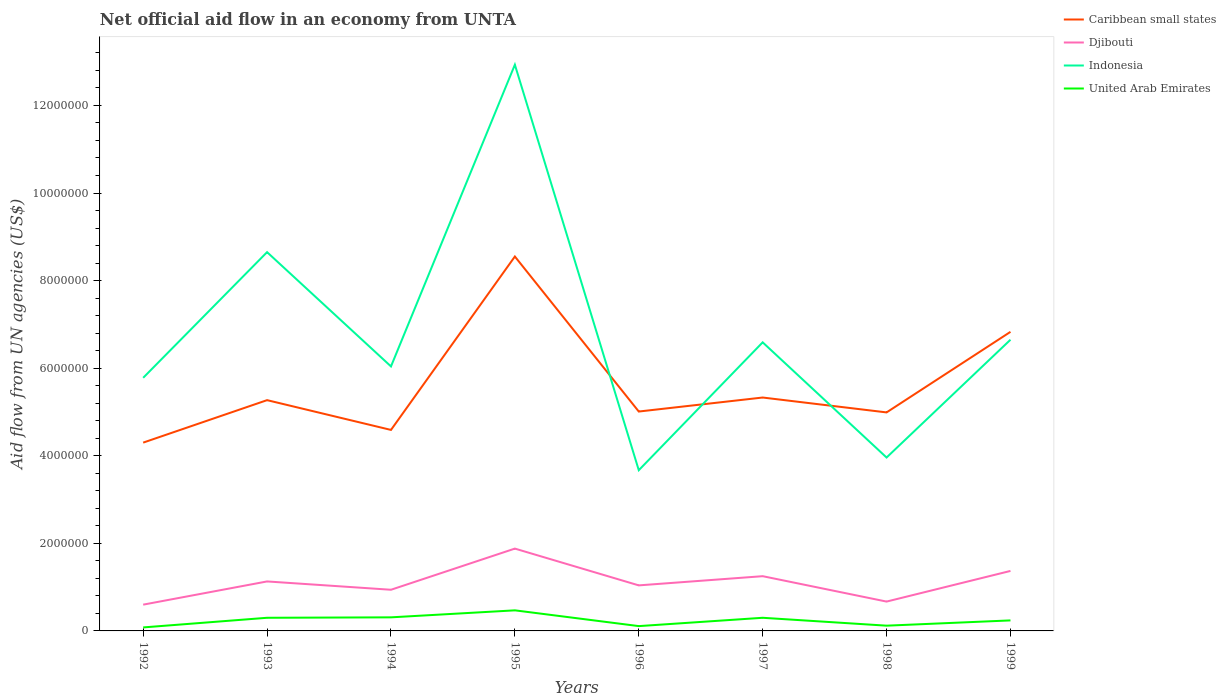How many different coloured lines are there?
Provide a succinct answer. 4. Does the line corresponding to United Arab Emirates intersect with the line corresponding to Djibouti?
Provide a succinct answer. No. Is the number of lines equal to the number of legend labels?
Keep it short and to the point. Yes. Across all years, what is the maximum net official aid flow in Indonesia?
Keep it short and to the point. 3.67e+06. What is the total net official aid flow in Indonesia in the graph?
Make the answer very short. 2.06e+06. What is the difference between the highest and the second highest net official aid flow in United Arab Emirates?
Offer a terse response. 3.90e+05. How many lines are there?
Offer a very short reply. 4. How many years are there in the graph?
Offer a very short reply. 8. Are the values on the major ticks of Y-axis written in scientific E-notation?
Make the answer very short. No. Does the graph contain any zero values?
Keep it short and to the point. No. Does the graph contain grids?
Give a very brief answer. No. Where does the legend appear in the graph?
Your response must be concise. Top right. How many legend labels are there?
Your answer should be compact. 4. How are the legend labels stacked?
Offer a very short reply. Vertical. What is the title of the graph?
Provide a short and direct response. Net official aid flow in an economy from UNTA. What is the label or title of the X-axis?
Your answer should be very brief. Years. What is the label or title of the Y-axis?
Provide a short and direct response. Aid flow from UN agencies (US$). What is the Aid flow from UN agencies (US$) of Caribbean small states in 1992?
Offer a very short reply. 4.30e+06. What is the Aid flow from UN agencies (US$) of Djibouti in 1992?
Give a very brief answer. 6.00e+05. What is the Aid flow from UN agencies (US$) in Indonesia in 1992?
Offer a very short reply. 5.78e+06. What is the Aid flow from UN agencies (US$) of United Arab Emirates in 1992?
Your answer should be very brief. 8.00e+04. What is the Aid flow from UN agencies (US$) of Caribbean small states in 1993?
Your answer should be compact. 5.27e+06. What is the Aid flow from UN agencies (US$) in Djibouti in 1993?
Your answer should be compact. 1.13e+06. What is the Aid flow from UN agencies (US$) of Indonesia in 1993?
Your response must be concise. 8.65e+06. What is the Aid flow from UN agencies (US$) in United Arab Emirates in 1993?
Offer a terse response. 3.00e+05. What is the Aid flow from UN agencies (US$) in Caribbean small states in 1994?
Give a very brief answer. 4.59e+06. What is the Aid flow from UN agencies (US$) in Djibouti in 1994?
Keep it short and to the point. 9.40e+05. What is the Aid flow from UN agencies (US$) in Indonesia in 1994?
Offer a very short reply. 6.04e+06. What is the Aid flow from UN agencies (US$) in United Arab Emirates in 1994?
Give a very brief answer. 3.10e+05. What is the Aid flow from UN agencies (US$) in Caribbean small states in 1995?
Provide a short and direct response. 8.55e+06. What is the Aid flow from UN agencies (US$) of Djibouti in 1995?
Keep it short and to the point. 1.88e+06. What is the Aid flow from UN agencies (US$) of Indonesia in 1995?
Ensure brevity in your answer.  1.29e+07. What is the Aid flow from UN agencies (US$) of United Arab Emirates in 1995?
Your answer should be compact. 4.70e+05. What is the Aid flow from UN agencies (US$) of Caribbean small states in 1996?
Provide a short and direct response. 5.01e+06. What is the Aid flow from UN agencies (US$) of Djibouti in 1996?
Ensure brevity in your answer.  1.04e+06. What is the Aid flow from UN agencies (US$) in Indonesia in 1996?
Offer a very short reply. 3.67e+06. What is the Aid flow from UN agencies (US$) of Caribbean small states in 1997?
Offer a terse response. 5.33e+06. What is the Aid flow from UN agencies (US$) of Djibouti in 1997?
Your response must be concise. 1.25e+06. What is the Aid flow from UN agencies (US$) of Indonesia in 1997?
Your response must be concise. 6.59e+06. What is the Aid flow from UN agencies (US$) of Caribbean small states in 1998?
Your answer should be very brief. 4.99e+06. What is the Aid flow from UN agencies (US$) of Djibouti in 1998?
Offer a very short reply. 6.70e+05. What is the Aid flow from UN agencies (US$) of Indonesia in 1998?
Offer a very short reply. 3.96e+06. What is the Aid flow from UN agencies (US$) in Caribbean small states in 1999?
Provide a short and direct response. 6.83e+06. What is the Aid flow from UN agencies (US$) in Djibouti in 1999?
Give a very brief answer. 1.37e+06. What is the Aid flow from UN agencies (US$) of Indonesia in 1999?
Provide a short and direct response. 6.65e+06. Across all years, what is the maximum Aid flow from UN agencies (US$) of Caribbean small states?
Make the answer very short. 8.55e+06. Across all years, what is the maximum Aid flow from UN agencies (US$) of Djibouti?
Your answer should be compact. 1.88e+06. Across all years, what is the maximum Aid flow from UN agencies (US$) in Indonesia?
Your response must be concise. 1.29e+07. Across all years, what is the maximum Aid flow from UN agencies (US$) of United Arab Emirates?
Ensure brevity in your answer.  4.70e+05. Across all years, what is the minimum Aid flow from UN agencies (US$) of Caribbean small states?
Offer a very short reply. 4.30e+06. Across all years, what is the minimum Aid flow from UN agencies (US$) of Djibouti?
Keep it short and to the point. 6.00e+05. Across all years, what is the minimum Aid flow from UN agencies (US$) of Indonesia?
Offer a terse response. 3.67e+06. What is the total Aid flow from UN agencies (US$) of Caribbean small states in the graph?
Give a very brief answer. 4.49e+07. What is the total Aid flow from UN agencies (US$) of Djibouti in the graph?
Ensure brevity in your answer.  8.88e+06. What is the total Aid flow from UN agencies (US$) of Indonesia in the graph?
Give a very brief answer. 5.43e+07. What is the total Aid flow from UN agencies (US$) in United Arab Emirates in the graph?
Keep it short and to the point. 1.93e+06. What is the difference between the Aid flow from UN agencies (US$) in Caribbean small states in 1992 and that in 1993?
Offer a very short reply. -9.70e+05. What is the difference between the Aid flow from UN agencies (US$) in Djibouti in 1992 and that in 1993?
Your answer should be very brief. -5.30e+05. What is the difference between the Aid flow from UN agencies (US$) in Indonesia in 1992 and that in 1993?
Your answer should be very brief. -2.87e+06. What is the difference between the Aid flow from UN agencies (US$) of United Arab Emirates in 1992 and that in 1993?
Ensure brevity in your answer.  -2.20e+05. What is the difference between the Aid flow from UN agencies (US$) of Caribbean small states in 1992 and that in 1994?
Keep it short and to the point. -2.90e+05. What is the difference between the Aid flow from UN agencies (US$) of Djibouti in 1992 and that in 1994?
Make the answer very short. -3.40e+05. What is the difference between the Aid flow from UN agencies (US$) in Caribbean small states in 1992 and that in 1995?
Provide a short and direct response. -4.25e+06. What is the difference between the Aid flow from UN agencies (US$) of Djibouti in 1992 and that in 1995?
Offer a very short reply. -1.28e+06. What is the difference between the Aid flow from UN agencies (US$) of Indonesia in 1992 and that in 1995?
Give a very brief answer. -7.15e+06. What is the difference between the Aid flow from UN agencies (US$) in United Arab Emirates in 1992 and that in 1995?
Your response must be concise. -3.90e+05. What is the difference between the Aid flow from UN agencies (US$) in Caribbean small states in 1992 and that in 1996?
Your answer should be compact. -7.10e+05. What is the difference between the Aid flow from UN agencies (US$) of Djibouti in 1992 and that in 1996?
Your answer should be compact. -4.40e+05. What is the difference between the Aid flow from UN agencies (US$) of Indonesia in 1992 and that in 1996?
Keep it short and to the point. 2.11e+06. What is the difference between the Aid flow from UN agencies (US$) in United Arab Emirates in 1992 and that in 1996?
Provide a short and direct response. -3.00e+04. What is the difference between the Aid flow from UN agencies (US$) of Caribbean small states in 1992 and that in 1997?
Ensure brevity in your answer.  -1.03e+06. What is the difference between the Aid flow from UN agencies (US$) of Djibouti in 1992 and that in 1997?
Your answer should be compact. -6.50e+05. What is the difference between the Aid flow from UN agencies (US$) of Indonesia in 1992 and that in 1997?
Provide a succinct answer. -8.10e+05. What is the difference between the Aid flow from UN agencies (US$) of United Arab Emirates in 1992 and that in 1997?
Ensure brevity in your answer.  -2.20e+05. What is the difference between the Aid flow from UN agencies (US$) of Caribbean small states in 1992 and that in 1998?
Provide a succinct answer. -6.90e+05. What is the difference between the Aid flow from UN agencies (US$) of Djibouti in 1992 and that in 1998?
Keep it short and to the point. -7.00e+04. What is the difference between the Aid flow from UN agencies (US$) in Indonesia in 1992 and that in 1998?
Ensure brevity in your answer.  1.82e+06. What is the difference between the Aid flow from UN agencies (US$) of United Arab Emirates in 1992 and that in 1998?
Provide a short and direct response. -4.00e+04. What is the difference between the Aid flow from UN agencies (US$) in Caribbean small states in 1992 and that in 1999?
Give a very brief answer. -2.53e+06. What is the difference between the Aid flow from UN agencies (US$) of Djibouti in 1992 and that in 1999?
Your response must be concise. -7.70e+05. What is the difference between the Aid flow from UN agencies (US$) in Indonesia in 1992 and that in 1999?
Ensure brevity in your answer.  -8.70e+05. What is the difference between the Aid flow from UN agencies (US$) in United Arab Emirates in 1992 and that in 1999?
Provide a succinct answer. -1.60e+05. What is the difference between the Aid flow from UN agencies (US$) of Caribbean small states in 1993 and that in 1994?
Ensure brevity in your answer.  6.80e+05. What is the difference between the Aid flow from UN agencies (US$) in Indonesia in 1993 and that in 1994?
Ensure brevity in your answer.  2.61e+06. What is the difference between the Aid flow from UN agencies (US$) in Caribbean small states in 1993 and that in 1995?
Provide a short and direct response. -3.28e+06. What is the difference between the Aid flow from UN agencies (US$) in Djibouti in 1993 and that in 1995?
Your response must be concise. -7.50e+05. What is the difference between the Aid flow from UN agencies (US$) in Indonesia in 1993 and that in 1995?
Give a very brief answer. -4.28e+06. What is the difference between the Aid flow from UN agencies (US$) of Djibouti in 1993 and that in 1996?
Provide a succinct answer. 9.00e+04. What is the difference between the Aid flow from UN agencies (US$) of Indonesia in 1993 and that in 1996?
Keep it short and to the point. 4.98e+06. What is the difference between the Aid flow from UN agencies (US$) in United Arab Emirates in 1993 and that in 1996?
Make the answer very short. 1.90e+05. What is the difference between the Aid flow from UN agencies (US$) in Indonesia in 1993 and that in 1997?
Keep it short and to the point. 2.06e+06. What is the difference between the Aid flow from UN agencies (US$) in United Arab Emirates in 1993 and that in 1997?
Provide a succinct answer. 0. What is the difference between the Aid flow from UN agencies (US$) in Djibouti in 1993 and that in 1998?
Your answer should be compact. 4.60e+05. What is the difference between the Aid flow from UN agencies (US$) of Indonesia in 1993 and that in 1998?
Ensure brevity in your answer.  4.69e+06. What is the difference between the Aid flow from UN agencies (US$) in United Arab Emirates in 1993 and that in 1998?
Keep it short and to the point. 1.80e+05. What is the difference between the Aid flow from UN agencies (US$) in Caribbean small states in 1993 and that in 1999?
Your answer should be compact. -1.56e+06. What is the difference between the Aid flow from UN agencies (US$) of Djibouti in 1993 and that in 1999?
Provide a succinct answer. -2.40e+05. What is the difference between the Aid flow from UN agencies (US$) in Caribbean small states in 1994 and that in 1995?
Provide a succinct answer. -3.96e+06. What is the difference between the Aid flow from UN agencies (US$) of Djibouti in 1994 and that in 1995?
Make the answer very short. -9.40e+05. What is the difference between the Aid flow from UN agencies (US$) in Indonesia in 1994 and that in 1995?
Your response must be concise. -6.89e+06. What is the difference between the Aid flow from UN agencies (US$) in Caribbean small states in 1994 and that in 1996?
Offer a very short reply. -4.20e+05. What is the difference between the Aid flow from UN agencies (US$) in Indonesia in 1994 and that in 1996?
Keep it short and to the point. 2.37e+06. What is the difference between the Aid flow from UN agencies (US$) in United Arab Emirates in 1994 and that in 1996?
Your response must be concise. 2.00e+05. What is the difference between the Aid flow from UN agencies (US$) in Caribbean small states in 1994 and that in 1997?
Your answer should be very brief. -7.40e+05. What is the difference between the Aid flow from UN agencies (US$) in Djibouti in 1994 and that in 1997?
Provide a succinct answer. -3.10e+05. What is the difference between the Aid flow from UN agencies (US$) of Indonesia in 1994 and that in 1997?
Ensure brevity in your answer.  -5.50e+05. What is the difference between the Aid flow from UN agencies (US$) of United Arab Emirates in 1994 and that in 1997?
Your answer should be compact. 10000. What is the difference between the Aid flow from UN agencies (US$) in Caribbean small states in 1994 and that in 1998?
Make the answer very short. -4.00e+05. What is the difference between the Aid flow from UN agencies (US$) in Djibouti in 1994 and that in 1998?
Keep it short and to the point. 2.70e+05. What is the difference between the Aid flow from UN agencies (US$) of Indonesia in 1994 and that in 1998?
Make the answer very short. 2.08e+06. What is the difference between the Aid flow from UN agencies (US$) of United Arab Emirates in 1994 and that in 1998?
Ensure brevity in your answer.  1.90e+05. What is the difference between the Aid flow from UN agencies (US$) in Caribbean small states in 1994 and that in 1999?
Keep it short and to the point. -2.24e+06. What is the difference between the Aid flow from UN agencies (US$) of Djibouti in 1994 and that in 1999?
Provide a short and direct response. -4.30e+05. What is the difference between the Aid flow from UN agencies (US$) in Indonesia in 1994 and that in 1999?
Your answer should be very brief. -6.10e+05. What is the difference between the Aid flow from UN agencies (US$) in United Arab Emirates in 1994 and that in 1999?
Your response must be concise. 7.00e+04. What is the difference between the Aid flow from UN agencies (US$) of Caribbean small states in 1995 and that in 1996?
Offer a terse response. 3.54e+06. What is the difference between the Aid flow from UN agencies (US$) in Djibouti in 1995 and that in 1996?
Provide a succinct answer. 8.40e+05. What is the difference between the Aid flow from UN agencies (US$) in Indonesia in 1995 and that in 1996?
Your response must be concise. 9.26e+06. What is the difference between the Aid flow from UN agencies (US$) in Caribbean small states in 1995 and that in 1997?
Your response must be concise. 3.22e+06. What is the difference between the Aid flow from UN agencies (US$) in Djibouti in 1995 and that in 1997?
Ensure brevity in your answer.  6.30e+05. What is the difference between the Aid flow from UN agencies (US$) of Indonesia in 1995 and that in 1997?
Keep it short and to the point. 6.34e+06. What is the difference between the Aid flow from UN agencies (US$) of United Arab Emirates in 1995 and that in 1997?
Provide a short and direct response. 1.70e+05. What is the difference between the Aid flow from UN agencies (US$) of Caribbean small states in 1995 and that in 1998?
Provide a short and direct response. 3.56e+06. What is the difference between the Aid flow from UN agencies (US$) in Djibouti in 1995 and that in 1998?
Give a very brief answer. 1.21e+06. What is the difference between the Aid flow from UN agencies (US$) of Indonesia in 1995 and that in 1998?
Your response must be concise. 8.97e+06. What is the difference between the Aid flow from UN agencies (US$) in Caribbean small states in 1995 and that in 1999?
Offer a terse response. 1.72e+06. What is the difference between the Aid flow from UN agencies (US$) in Djibouti in 1995 and that in 1999?
Give a very brief answer. 5.10e+05. What is the difference between the Aid flow from UN agencies (US$) of Indonesia in 1995 and that in 1999?
Offer a terse response. 6.28e+06. What is the difference between the Aid flow from UN agencies (US$) of United Arab Emirates in 1995 and that in 1999?
Give a very brief answer. 2.30e+05. What is the difference between the Aid flow from UN agencies (US$) in Caribbean small states in 1996 and that in 1997?
Ensure brevity in your answer.  -3.20e+05. What is the difference between the Aid flow from UN agencies (US$) of Djibouti in 1996 and that in 1997?
Provide a short and direct response. -2.10e+05. What is the difference between the Aid flow from UN agencies (US$) in Indonesia in 1996 and that in 1997?
Keep it short and to the point. -2.92e+06. What is the difference between the Aid flow from UN agencies (US$) of United Arab Emirates in 1996 and that in 1997?
Provide a short and direct response. -1.90e+05. What is the difference between the Aid flow from UN agencies (US$) in Djibouti in 1996 and that in 1998?
Offer a terse response. 3.70e+05. What is the difference between the Aid flow from UN agencies (US$) in Caribbean small states in 1996 and that in 1999?
Offer a very short reply. -1.82e+06. What is the difference between the Aid flow from UN agencies (US$) of Djibouti in 1996 and that in 1999?
Your answer should be very brief. -3.30e+05. What is the difference between the Aid flow from UN agencies (US$) in Indonesia in 1996 and that in 1999?
Your answer should be very brief. -2.98e+06. What is the difference between the Aid flow from UN agencies (US$) of United Arab Emirates in 1996 and that in 1999?
Provide a short and direct response. -1.30e+05. What is the difference between the Aid flow from UN agencies (US$) in Caribbean small states in 1997 and that in 1998?
Your response must be concise. 3.40e+05. What is the difference between the Aid flow from UN agencies (US$) of Djibouti in 1997 and that in 1998?
Make the answer very short. 5.80e+05. What is the difference between the Aid flow from UN agencies (US$) in Indonesia in 1997 and that in 1998?
Provide a succinct answer. 2.63e+06. What is the difference between the Aid flow from UN agencies (US$) in Caribbean small states in 1997 and that in 1999?
Your answer should be very brief. -1.50e+06. What is the difference between the Aid flow from UN agencies (US$) of United Arab Emirates in 1997 and that in 1999?
Give a very brief answer. 6.00e+04. What is the difference between the Aid flow from UN agencies (US$) of Caribbean small states in 1998 and that in 1999?
Offer a very short reply. -1.84e+06. What is the difference between the Aid flow from UN agencies (US$) of Djibouti in 1998 and that in 1999?
Ensure brevity in your answer.  -7.00e+05. What is the difference between the Aid flow from UN agencies (US$) in Indonesia in 1998 and that in 1999?
Your answer should be compact. -2.69e+06. What is the difference between the Aid flow from UN agencies (US$) in United Arab Emirates in 1998 and that in 1999?
Your answer should be compact. -1.20e+05. What is the difference between the Aid flow from UN agencies (US$) of Caribbean small states in 1992 and the Aid flow from UN agencies (US$) of Djibouti in 1993?
Offer a terse response. 3.17e+06. What is the difference between the Aid flow from UN agencies (US$) in Caribbean small states in 1992 and the Aid flow from UN agencies (US$) in Indonesia in 1993?
Ensure brevity in your answer.  -4.35e+06. What is the difference between the Aid flow from UN agencies (US$) in Caribbean small states in 1992 and the Aid flow from UN agencies (US$) in United Arab Emirates in 1993?
Your answer should be very brief. 4.00e+06. What is the difference between the Aid flow from UN agencies (US$) of Djibouti in 1992 and the Aid flow from UN agencies (US$) of Indonesia in 1993?
Offer a very short reply. -8.05e+06. What is the difference between the Aid flow from UN agencies (US$) of Indonesia in 1992 and the Aid flow from UN agencies (US$) of United Arab Emirates in 1993?
Offer a very short reply. 5.48e+06. What is the difference between the Aid flow from UN agencies (US$) in Caribbean small states in 1992 and the Aid flow from UN agencies (US$) in Djibouti in 1994?
Your response must be concise. 3.36e+06. What is the difference between the Aid flow from UN agencies (US$) in Caribbean small states in 1992 and the Aid flow from UN agencies (US$) in Indonesia in 1994?
Give a very brief answer. -1.74e+06. What is the difference between the Aid flow from UN agencies (US$) of Caribbean small states in 1992 and the Aid flow from UN agencies (US$) of United Arab Emirates in 1994?
Keep it short and to the point. 3.99e+06. What is the difference between the Aid flow from UN agencies (US$) of Djibouti in 1992 and the Aid flow from UN agencies (US$) of Indonesia in 1994?
Ensure brevity in your answer.  -5.44e+06. What is the difference between the Aid flow from UN agencies (US$) of Indonesia in 1992 and the Aid flow from UN agencies (US$) of United Arab Emirates in 1994?
Give a very brief answer. 5.47e+06. What is the difference between the Aid flow from UN agencies (US$) of Caribbean small states in 1992 and the Aid flow from UN agencies (US$) of Djibouti in 1995?
Provide a short and direct response. 2.42e+06. What is the difference between the Aid flow from UN agencies (US$) in Caribbean small states in 1992 and the Aid flow from UN agencies (US$) in Indonesia in 1995?
Ensure brevity in your answer.  -8.63e+06. What is the difference between the Aid flow from UN agencies (US$) in Caribbean small states in 1992 and the Aid flow from UN agencies (US$) in United Arab Emirates in 1995?
Keep it short and to the point. 3.83e+06. What is the difference between the Aid flow from UN agencies (US$) in Djibouti in 1992 and the Aid flow from UN agencies (US$) in Indonesia in 1995?
Keep it short and to the point. -1.23e+07. What is the difference between the Aid flow from UN agencies (US$) in Djibouti in 1992 and the Aid flow from UN agencies (US$) in United Arab Emirates in 1995?
Offer a terse response. 1.30e+05. What is the difference between the Aid flow from UN agencies (US$) in Indonesia in 1992 and the Aid flow from UN agencies (US$) in United Arab Emirates in 1995?
Provide a succinct answer. 5.31e+06. What is the difference between the Aid flow from UN agencies (US$) of Caribbean small states in 1992 and the Aid flow from UN agencies (US$) of Djibouti in 1996?
Your answer should be very brief. 3.26e+06. What is the difference between the Aid flow from UN agencies (US$) of Caribbean small states in 1992 and the Aid flow from UN agencies (US$) of Indonesia in 1996?
Keep it short and to the point. 6.30e+05. What is the difference between the Aid flow from UN agencies (US$) of Caribbean small states in 1992 and the Aid flow from UN agencies (US$) of United Arab Emirates in 1996?
Your response must be concise. 4.19e+06. What is the difference between the Aid flow from UN agencies (US$) of Djibouti in 1992 and the Aid flow from UN agencies (US$) of Indonesia in 1996?
Give a very brief answer. -3.07e+06. What is the difference between the Aid flow from UN agencies (US$) of Djibouti in 1992 and the Aid flow from UN agencies (US$) of United Arab Emirates in 1996?
Give a very brief answer. 4.90e+05. What is the difference between the Aid flow from UN agencies (US$) in Indonesia in 1992 and the Aid flow from UN agencies (US$) in United Arab Emirates in 1996?
Keep it short and to the point. 5.67e+06. What is the difference between the Aid flow from UN agencies (US$) of Caribbean small states in 1992 and the Aid flow from UN agencies (US$) of Djibouti in 1997?
Offer a very short reply. 3.05e+06. What is the difference between the Aid flow from UN agencies (US$) in Caribbean small states in 1992 and the Aid flow from UN agencies (US$) in Indonesia in 1997?
Offer a terse response. -2.29e+06. What is the difference between the Aid flow from UN agencies (US$) of Caribbean small states in 1992 and the Aid flow from UN agencies (US$) of United Arab Emirates in 1997?
Make the answer very short. 4.00e+06. What is the difference between the Aid flow from UN agencies (US$) in Djibouti in 1992 and the Aid flow from UN agencies (US$) in Indonesia in 1997?
Make the answer very short. -5.99e+06. What is the difference between the Aid flow from UN agencies (US$) of Indonesia in 1992 and the Aid flow from UN agencies (US$) of United Arab Emirates in 1997?
Give a very brief answer. 5.48e+06. What is the difference between the Aid flow from UN agencies (US$) in Caribbean small states in 1992 and the Aid flow from UN agencies (US$) in Djibouti in 1998?
Give a very brief answer. 3.63e+06. What is the difference between the Aid flow from UN agencies (US$) in Caribbean small states in 1992 and the Aid flow from UN agencies (US$) in Indonesia in 1998?
Your answer should be compact. 3.40e+05. What is the difference between the Aid flow from UN agencies (US$) of Caribbean small states in 1992 and the Aid flow from UN agencies (US$) of United Arab Emirates in 1998?
Your answer should be very brief. 4.18e+06. What is the difference between the Aid flow from UN agencies (US$) of Djibouti in 1992 and the Aid flow from UN agencies (US$) of Indonesia in 1998?
Offer a very short reply. -3.36e+06. What is the difference between the Aid flow from UN agencies (US$) of Djibouti in 1992 and the Aid flow from UN agencies (US$) of United Arab Emirates in 1998?
Offer a very short reply. 4.80e+05. What is the difference between the Aid flow from UN agencies (US$) of Indonesia in 1992 and the Aid flow from UN agencies (US$) of United Arab Emirates in 1998?
Offer a very short reply. 5.66e+06. What is the difference between the Aid flow from UN agencies (US$) of Caribbean small states in 1992 and the Aid flow from UN agencies (US$) of Djibouti in 1999?
Keep it short and to the point. 2.93e+06. What is the difference between the Aid flow from UN agencies (US$) of Caribbean small states in 1992 and the Aid flow from UN agencies (US$) of Indonesia in 1999?
Offer a very short reply. -2.35e+06. What is the difference between the Aid flow from UN agencies (US$) in Caribbean small states in 1992 and the Aid flow from UN agencies (US$) in United Arab Emirates in 1999?
Give a very brief answer. 4.06e+06. What is the difference between the Aid flow from UN agencies (US$) in Djibouti in 1992 and the Aid flow from UN agencies (US$) in Indonesia in 1999?
Your answer should be very brief. -6.05e+06. What is the difference between the Aid flow from UN agencies (US$) of Indonesia in 1992 and the Aid flow from UN agencies (US$) of United Arab Emirates in 1999?
Offer a very short reply. 5.54e+06. What is the difference between the Aid flow from UN agencies (US$) in Caribbean small states in 1993 and the Aid flow from UN agencies (US$) in Djibouti in 1994?
Keep it short and to the point. 4.33e+06. What is the difference between the Aid flow from UN agencies (US$) of Caribbean small states in 1993 and the Aid flow from UN agencies (US$) of Indonesia in 1994?
Ensure brevity in your answer.  -7.70e+05. What is the difference between the Aid flow from UN agencies (US$) of Caribbean small states in 1993 and the Aid flow from UN agencies (US$) of United Arab Emirates in 1994?
Ensure brevity in your answer.  4.96e+06. What is the difference between the Aid flow from UN agencies (US$) of Djibouti in 1993 and the Aid flow from UN agencies (US$) of Indonesia in 1994?
Provide a succinct answer. -4.91e+06. What is the difference between the Aid flow from UN agencies (US$) in Djibouti in 1993 and the Aid flow from UN agencies (US$) in United Arab Emirates in 1994?
Your answer should be compact. 8.20e+05. What is the difference between the Aid flow from UN agencies (US$) in Indonesia in 1993 and the Aid flow from UN agencies (US$) in United Arab Emirates in 1994?
Give a very brief answer. 8.34e+06. What is the difference between the Aid flow from UN agencies (US$) in Caribbean small states in 1993 and the Aid flow from UN agencies (US$) in Djibouti in 1995?
Offer a terse response. 3.39e+06. What is the difference between the Aid flow from UN agencies (US$) of Caribbean small states in 1993 and the Aid flow from UN agencies (US$) of Indonesia in 1995?
Provide a succinct answer. -7.66e+06. What is the difference between the Aid flow from UN agencies (US$) in Caribbean small states in 1993 and the Aid flow from UN agencies (US$) in United Arab Emirates in 1995?
Your answer should be compact. 4.80e+06. What is the difference between the Aid flow from UN agencies (US$) of Djibouti in 1993 and the Aid flow from UN agencies (US$) of Indonesia in 1995?
Offer a very short reply. -1.18e+07. What is the difference between the Aid flow from UN agencies (US$) in Djibouti in 1993 and the Aid flow from UN agencies (US$) in United Arab Emirates in 1995?
Keep it short and to the point. 6.60e+05. What is the difference between the Aid flow from UN agencies (US$) in Indonesia in 1993 and the Aid flow from UN agencies (US$) in United Arab Emirates in 1995?
Your answer should be compact. 8.18e+06. What is the difference between the Aid flow from UN agencies (US$) in Caribbean small states in 1993 and the Aid flow from UN agencies (US$) in Djibouti in 1996?
Your answer should be compact. 4.23e+06. What is the difference between the Aid flow from UN agencies (US$) in Caribbean small states in 1993 and the Aid flow from UN agencies (US$) in Indonesia in 1996?
Give a very brief answer. 1.60e+06. What is the difference between the Aid flow from UN agencies (US$) of Caribbean small states in 1993 and the Aid flow from UN agencies (US$) of United Arab Emirates in 1996?
Provide a short and direct response. 5.16e+06. What is the difference between the Aid flow from UN agencies (US$) in Djibouti in 1993 and the Aid flow from UN agencies (US$) in Indonesia in 1996?
Your answer should be very brief. -2.54e+06. What is the difference between the Aid flow from UN agencies (US$) in Djibouti in 1993 and the Aid flow from UN agencies (US$) in United Arab Emirates in 1996?
Keep it short and to the point. 1.02e+06. What is the difference between the Aid flow from UN agencies (US$) in Indonesia in 1993 and the Aid flow from UN agencies (US$) in United Arab Emirates in 1996?
Your response must be concise. 8.54e+06. What is the difference between the Aid flow from UN agencies (US$) in Caribbean small states in 1993 and the Aid flow from UN agencies (US$) in Djibouti in 1997?
Keep it short and to the point. 4.02e+06. What is the difference between the Aid flow from UN agencies (US$) in Caribbean small states in 1993 and the Aid flow from UN agencies (US$) in Indonesia in 1997?
Keep it short and to the point. -1.32e+06. What is the difference between the Aid flow from UN agencies (US$) of Caribbean small states in 1993 and the Aid flow from UN agencies (US$) of United Arab Emirates in 1997?
Your response must be concise. 4.97e+06. What is the difference between the Aid flow from UN agencies (US$) in Djibouti in 1993 and the Aid flow from UN agencies (US$) in Indonesia in 1997?
Make the answer very short. -5.46e+06. What is the difference between the Aid flow from UN agencies (US$) of Djibouti in 1993 and the Aid flow from UN agencies (US$) of United Arab Emirates in 1997?
Make the answer very short. 8.30e+05. What is the difference between the Aid flow from UN agencies (US$) in Indonesia in 1993 and the Aid flow from UN agencies (US$) in United Arab Emirates in 1997?
Provide a short and direct response. 8.35e+06. What is the difference between the Aid flow from UN agencies (US$) of Caribbean small states in 1993 and the Aid flow from UN agencies (US$) of Djibouti in 1998?
Your answer should be compact. 4.60e+06. What is the difference between the Aid flow from UN agencies (US$) in Caribbean small states in 1993 and the Aid flow from UN agencies (US$) in Indonesia in 1998?
Your answer should be compact. 1.31e+06. What is the difference between the Aid flow from UN agencies (US$) of Caribbean small states in 1993 and the Aid flow from UN agencies (US$) of United Arab Emirates in 1998?
Offer a terse response. 5.15e+06. What is the difference between the Aid flow from UN agencies (US$) of Djibouti in 1993 and the Aid flow from UN agencies (US$) of Indonesia in 1998?
Offer a terse response. -2.83e+06. What is the difference between the Aid flow from UN agencies (US$) of Djibouti in 1993 and the Aid flow from UN agencies (US$) of United Arab Emirates in 1998?
Give a very brief answer. 1.01e+06. What is the difference between the Aid flow from UN agencies (US$) of Indonesia in 1993 and the Aid flow from UN agencies (US$) of United Arab Emirates in 1998?
Offer a very short reply. 8.53e+06. What is the difference between the Aid flow from UN agencies (US$) of Caribbean small states in 1993 and the Aid flow from UN agencies (US$) of Djibouti in 1999?
Your response must be concise. 3.90e+06. What is the difference between the Aid flow from UN agencies (US$) of Caribbean small states in 1993 and the Aid flow from UN agencies (US$) of Indonesia in 1999?
Your answer should be compact. -1.38e+06. What is the difference between the Aid flow from UN agencies (US$) of Caribbean small states in 1993 and the Aid flow from UN agencies (US$) of United Arab Emirates in 1999?
Your answer should be compact. 5.03e+06. What is the difference between the Aid flow from UN agencies (US$) in Djibouti in 1993 and the Aid flow from UN agencies (US$) in Indonesia in 1999?
Provide a short and direct response. -5.52e+06. What is the difference between the Aid flow from UN agencies (US$) in Djibouti in 1993 and the Aid flow from UN agencies (US$) in United Arab Emirates in 1999?
Keep it short and to the point. 8.90e+05. What is the difference between the Aid flow from UN agencies (US$) in Indonesia in 1993 and the Aid flow from UN agencies (US$) in United Arab Emirates in 1999?
Give a very brief answer. 8.41e+06. What is the difference between the Aid flow from UN agencies (US$) in Caribbean small states in 1994 and the Aid flow from UN agencies (US$) in Djibouti in 1995?
Your response must be concise. 2.71e+06. What is the difference between the Aid flow from UN agencies (US$) in Caribbean small states in 1994 and the Aid flow from UN agencies (US$) in Indonesia in 1995?
Give a very brief answer. -8.34e+06. What is the difference between the Aid flow from UN agencies (US$) in Caribbean small states in 1994 and the Aid flow from UN agencies (US$) in United Arab Emirates in 1995?
Offer a very short reply. 4.12e+06. What is the difference between the Aid flow from UN agencies (US$) in Djibouti in 1994 and the Aid flow from UN agencies (US$) in Indonesia in 1995?
Give a very brief answer. -1.20e+07. What is the difference between the Aid flow from UN agencies (US$) of Indonesia in 1994 and the Aid flow from UN agencies (US$) of United Arab Emirates in 1995?
Your answer should be compact. 5.57e+06. What is the difference between the Aid flow from UN agencies (US$) in Caribbean small states in 1994 and the Aid flow from UN agencies (US$) in Djibouti in 1996?
Make the answer very short. 3.55e+06. What is the difference between the Aid flow from UN agencies (US$) in Caribbean small states in 1994 and the Aid flow from UN agencies (US$) in Indonesia in 1996?
Your answer should be compact. 9.20e+05. What is the difference between the Aid flow from UN agencies (US$) of Caribbean small states in 1994 and the Aid flow from UN agencies (US$) of United Arab Emirates in 1996?
Offer a terse response. 4.48e+06. What is the difference between the Aid flow from UN agencies (US$) of Djibouti in 1994 and the Aid flow from UN agencies (US$) of Indonesia in 1996?
Your response must be concise. -2.73e+06. What is the difference between the Aid flow from UN agencies (US$) in Djibouti in 1994 and the Aid flow from UN agencies (US$) in United Arab Emirates in 1996?
Offer a very short reply. 8.30e+05. What is the difference between the Aid flow from UN agencies (US$) of Indonesia in 1994 and the Aid flow from UN agencies (US$) of United Arab Emirates in 1996?
Offer a very short reply. 5.93e+06. What is the difference between the Aid flow from UN agencies (US$) of Caribbean small states in 1994 and the Aid flow from UN agencies (US$) of Djibouti in 1997?
Ensure brevity in your answer.  3.34e+06. What is the difference between the Aid flow from UN agencies (US$) of Caribbean small states in 1994 and the Aid flow from UN agencies (US$) of Indonesia in 1997?
Give a very brief answer. -2.00e+06. What is the difference between the Aid flow from UN agencies (US$) of Caribbean small states in 1994 and the Aid flow from UN agencies (US$) of United Arab Emirates in 1997?
Keep it short and to the point. 4.29e+06. What is the difference between the Aid flow from UN agencies (US$) of Djibouti in 1994 and the Aid flow from UN agencies (US$) of Indonesia in 1997?
Keep it short and to the point. -5.65e+06. What is the difference between the Aid flow from UN agencies (US$) of Djibouti in 1994 and the Aid flow from UN agencies (US$) of United Arab Emirates in 1997?
Provide a short and direct response. 6.40e+05. What is the difference between the Aid flow from UN agencies (US$) in Indonesia in 1994 and the Aid flow from UN agencies (US$) in United Arab Emirates in 1997?
Make the answer very short. 5.74e+06. What is the difference between the Aid flow from UN agencies (US$) of Caribbean small states in 1994 and the Aid flow from UN agencies (US$) of Djibouti in 1998?
Offer a terse response. 3.92e+06. What is the difference between the Aid flow from UN agencies (US$) of Caribbean small states in 1994 and the Aid flow from UN agencies (US$) of Indonesia in 1998?
Your response must be concise. 6.30e+05. What is the difference between the Aid flow from UN agencies (US$) of Caribbean small states in 1994 and the Aid flow from UN agencies (US$) of United Arab Emirates in 1998?
Give a very brief answer. 4.47e+06. What is the difference between the Aid flow from UN agencies (US$) of Djibouti in 1994 and the Aid flow from UN agencies (US$) of Indonesia in 1998?
Give a very brief answer. -3.02e+06. What is the difference between the Aid flow from UN agencies (US$) in Djibouti in 1994 and the Aid flow from UN agencies (US$) in United Arab Emirates in 1998?
Ensure brevity in your answer.  8.20e+05. What is the difference between the Aid flow from UN agencies (US$) in Indonesia in 1994 and the Aid flow from UN agencies (US$) in United Arab Emirates in 1998?
Make the answer very short. 5.92e+06. What is the difference between the Aid flow from UN agencies (US$) of Caribbean small states in 1994 and the Aid flow from UN agencies (US$) of Djibouti in 1999?
Provide a short and direct response. 3.22e+06. What is the difference between the Aid flow from UN agencies (US$) in Caribbean small states in 1994 and the Aid flow from UN agencies (US$) in Indonesia in 1999?
Offer a terse response. -2.06e+06. What is the difference between the Aid flow from UN agencies (US$) of Caribbean small states in 1994 and the Aid flow from UN agencies (US$) of United Arab Emirates in 1999?
Your response must be concise. 4.35e+06. What is the difference between the Aid flow from UN agencies (US$) in Djibouti in 1994 and the Aid flow from UN agencies (US$) in Indonesia in 1999?
Your answer should be compact. -5.71e+06. What is the difference between the Aid flow from UN agencies (US$) of Indonesia in 1994 and the Aid flow from UN agencies (US$) of United Arab Emirates in 1999?
Provide a succinct answer. 5.80e+06. What is the difference between the Aid flow from UN agencies (US$) in Caribbean small states in 1995 and the Aid flow from UN agencies (US$) in Djibouti in 1996?
Your response must be concise. 7.51e+06. What is the difference between the Aid flow from UN agencies (US$) in Caribbean small states in 1995 and the Aid flow from UN agencies (US$) in Indonesia in 1996?
Your answer should be very brief. 4.88e+06. What is the difference between the Aid flow from UN agencies (US$) of Caribbean small states in 1995 and the Aid flow from UN agencies (US$) of United Arab Emirates in 1996?
Offer a very short reply. 8.44e+06. What is the difference between the Aid flow from UN agencies (US$) in Djibouti in 1995 and the Aid flow from UN agencies (US$) in Indonesia in 1996?
Give a very brief answer. -1.79e+06. What is the difference between the Aid flow from UN agencies (US$) in Djibouti in 1995 and the Aid flow from UN agencies (US$) in United Arab Emirates in 1996?
Provide a succinct answer. 1.77e+06. What is the difference between the Aid flow from UN agencies (US$) of Indonesia in 1995 and the Aid flow from UN agencies (US$) of United Arab Emirates in 1996?
Your answer should be very brief. 1.28e+07. What is the difference between the Aid flow from UN agencies (US$) in Caribbean small states in 1995 and the Aid flow from UN agencies (US$) in Djibouti in 1997?
Your answer should be very brief. 7.30e+06. What is the difference between the Aid flow from UN agencies (US$) of Caribbean small states in 1995 and the Aid flow from UN agencies (US$) of Indonesia in 1997?
Your response must be concise. 1.96e+06. What is the difference between the Aid flow from UN agencies (US$) in Caribbean small states in 1995 and the Aid flow from UN agencies (US$) in United Arab Emirates in 1997?
Make the answer very short. 8.25e+06. What is the difference between the Aid flow from UN agencies (US$) of Djibouti in 1995 and the Aid flow from UN agencies (US$) of Indonesia in 1997?
Provide a succinct answer. -4.71e+06. What is the difference between the Aid flow from UN agencies (US$) in Djibouti in 1995 and the Aid flow from UN agencies (US$) in United Arab Emirates in 1997?
Make the answer very short. 1.58e+06. What is the difference between the Aid flow from UN agencies (US$) in Indonesia in 1995 and the Aid flow from UN agencies (US$) in United Arab Emirates in 1997?
Provide a short and direct response. 1.26e+07. What is the difference between the Aid flow from UN agencies (US$) in Caribbean small states in 1995 and the Aid flow from UN agencies (US$) in Djibouti in 1998?
Make the answer very short. 7.88e+06. What is the difference between the Aid flow from UN agencies (US$) of Caribbean small states in 1995 and the Aid flow from UN agencies (US$) of Indonesia in 1998?
Your answer should be compact. 4.59e+06. What is the difference between the Aid flow from UN agencies (US$) of Caribbean small states in 1995 and the Aid flow from UN agencies (US$) of United Arab Emirates in 1998?
Provide a short and direct response. 8.43e+06. What is the difference between the Aid flow from UN agencies (US$) of Djibouti in 1995 and the Aid flow from UN agencies (US$) of Indonesia in 1998?
Keep it short and to the point. -2.08e+06. What is the difference between the Aid flow from UN agencies (US$) in Djibouti in 1995 and the Aid flow from UN agencies (US$) in United Arab Emirates in 1998?
Keep it short and to the point. 1.76e+06. What is the difference between the Aid flow from UN agencies (US$) of Indonesia in 1995 and the Aid flow from UN agencies (US$) of United Arab Emirates in 1998?
Ensure brevity in your answer.  1.28e+07. What is the difference between the Aid flow from UN agencies (US$) in Caribbean small states in 1995 and the Aid flow from UN agencies (US$) in Djibouti in 1999?
Your answer should be very brief. 7.18e+06. What is the difference between the Aid flow from UN agencies (US$) in Caribbean small states in 1995 and the Aid flow from UN agencies (US$) in Indonesia in 1999?
Give a very brief answer. 1.90e+06. What is the difference between the Aid flow from UN agencies (US$) in Caribbean small states in 1995 and the Aid flow from UN agencies (US$) in United Arab Emirates in 1999?
Your answer should be very brief. 8.31e+06. What is the difference between the Aid flow from UN agencies (US$) in Djibouti in 1995 and the Aid flow from UN agencies (US$) in Indonesia in 1999?
Your answer should be compact. -4.77e+06. What is the difference between the Aid flow from UN agencies (US$) in Djibouti in 1995 and the Aid flow from UN agencies (US$) in United Arab Emirates in 1999?
Provide a succinct answer. 1.64e+06. What is the difference between the Aid flow from UN agencies (US$) of Indonesia in 1995 and the Aid flow from UN agencies (US$) of United Arab Emirates in 1999?
Provide a succinct answer. 1.27e+07. What is the difference between the Aid flow from UN agencies (US$) of Caribbean small states in 1996 and the Aid flow from UN agencies (US$) of Djibouti in 1997?
Give a very brief answer. 3.76e+06. What is the difference between the Aid flow from UN agencies (US$) of Caribbean small states in 1996 and the Aid flow from UN agencies (US$) of Indonesia in 1997?
Offer a very short reply. -1.58e+06. What is the difference between the Aid flow from UN agencies (US$) in Caribbean small states in 1996 and the Aid flow from UN agencies (US$) in United Arab Emirates in 1997?
Provide a succinct answer. 4.71e+06. What is the difference between the Aid flow from UN agencies (US$) of Djibouti in 1996 and the Aid flow from UN agencies (US$) of Indonesia in 1997?
Provide a succinct answer. -5.55e+06. What is the difference between the Aid flow from UN agencies (US$) of Djibouti in 1996 and the Aid flow from UN agencies (US$) of United Arab Emirates in 1997?
Ensure brevity in your answer.  7.40e+05. What is the difference between the Aid flow from UN agencies (US$) of Indonesia in 1996 and the Aid flow from UN agencies (US$) of United Arab Emirates in 1997?
Keep it short and to the point. 3.37e+06. What is the difference between the Aid flow from UN agencies (US$) of Caribbean small states in 1996 and the Aid flow from UN agencies (US$) of Djibouti in 1998?
Give a very brief answer. 4.34e+06. What is the difference between the Aid flow from UN agencies (US$) in Caribbean small states in 1996 and the Aid flow from UN agencies (US$) in Indonesia in 1998?
Your answer should be compact. 1.05e+06. What is the difference between the Aid flow from UN agencies (US$) of Caribbean small states in 1996 and the Aid flow from UN agencies (US$) of United Arab Emirates in 1998?
Keep it short and to the point. 4.89e+06. What is the difference between the Aid flow from UN agencies (US$) of Djibouti in 1996 and the Aid flow from UN agencies (US$) of Indonesia in 1998?
Your answer should be very brief. -2.92e+06. What is the difference between the Aid flow from UN agencies (US$) in Djibouti in 1996 and the Aid flow from UN agencies (US$) in United Arab Emirates in 1998?
Ensure brevity in your answer.  9.20e+05. What is the difference between the Aid flow from UN agencies (US$) of Indonesia in 1996 and the Aid flow from UN agencies (US$) of United Arab Emirates in 1998?
Provide a short and direct response. 3.55e+06. What is the difference between the Aid flow from UN agencies (US$) of Caribbean small states in 1996 and the Aid flow from UN agencies (US$) of Djibouti in 1999?
Your response must be concise. 3.64e+06. What is the difference between the Aid flow from UN agencies (US$) of Caribbean small states in 1996 and the Aid flow from UN agencies (US$) of Indonesia in 1999?
Keep it short and to the point. -1.64e+06. What is the difference between the Aid flow from UN agencies (US$) in Caribbean small states in 1996 and the Aid flow from UN agencies (US$) in United Arab Emirates in 1999?
Provide a succinct answer. 4.77e+06. What is the difference between the Aid flow from UN agencies (US$) of Djibouti in 1996 and the Aid flow from UN agencies (US$) of Indonesia in 1999?
Your answer should be very brief. -5.61e+06. What is the difference between the Aid flow from UN agencies (US$) in Djibouti in 1996 and the Aid flow from UN agencies (US$) in United Arab Emirates in 1999?
Your answer should be very brief. 8.00e+05. What is the difference between the Aid flow from UN agencies (US$) in Indonesia in 1996 and the Aid flow from UN agencies (US$) in United Arab Emirates in 1999?
Provide a succinct answer. 3.43e+06. What is the difference between the Aid flow from UN agencies (US$) of Caribbean small states in 1997 and the Aid flow from UN agencies (US$) of Djibouti in 1998?
Offer a very short reply. 4.66e+06. What is the difference between the Aid flow from UN agencies (US$) in Caribbean small states in 1997 and the Aid flow from UN agencies (US$) in Indonesia in 1998?
Keep it short and to the point. 1.37e+06. What is the difference between the Aid flow from UN agencies (US$) of Caribbean small states in 1997 and the Aid flow from UN agencies (US$) of United Arab Emirates in 1998?
Ensure brevity in your answer.  5.21e+06. What is the difference between the Aid flow from UN agencies (US$) in Djibouti in 1997 and the Aid flow from UN agencies (US$) in Indonesia in 1998?
Provide a short and direct response. -2.71e+06. What is the difference between the Aid flow from UN agencies (US$) of Djibouti in 1997 and the Aid flow from UN agencies (US$) of United Arab Emirates in 1998?
Give a very brief answer. 1.13e+06. What is the difference between the Aid flow from UN agencies (US$) of Indonesia in 1997 and the Aid flow from UN agencies (US$) of United Arab Emirates in 1998?
Provide a short and direct response. 6.47e+06. What is the difference between the Aid flow from UN agencies (US$) in Caribbean small states in 1997 and the Aid flow from UN agencies (US$) in Djibouti in 1999?
Ensure brevity in your answer.  3.96e+06. What is the difference between the Aid flow from UN agencies (US$) of Caribbean small states in 1997 and the Aid flow from UN agencies (US$) of Indonesia in 1999?
Offer a very short reply. -1.32e+06. What is the difference between the Aid flow from UN agencies (US$) of Caribbean small states in 1997 and the Aid flow from UN agencies (US$) of United Arab Emirates in 1999?
Make the answer very short. 5.09e+06. What is the difference between the Aid flow from UN agencies (US$) of Djibouti in 1997 and the Aid flow from UN agencies (US$) of Indonesia in 1999?
Provide a succinct answer. -5.40e+06. What is the difference between the Aid flow from UN agencies (US$) in Djibouti in 1997 and the Aid flow from UN agencies (US$) in United Arab Emirates in 1999?
Ensure brevity in your answer.  1.01e+06. What is the difference between the Aid flow from UN agencies (US$) in Indonesia in 1997 and the Aid flow from UN agencies (US$) in United Arab Emirates in 1999?
Your answer should be compact. 6.35e+06. What is the difference between the Aid flow from UN agencies (US$) of Caribbean small states in 1998 and the Aid flow from UN agencies (US$) of Djibouti in 1999?
Give a very brief answer. 3.62e+06. What is the difference between the Aid flow from UN agencies (US$) of Caribbean small states in 1998 and the Aid flow from UN agencies (US$) of Indonesia in 1999?
Offer a very short reply. -1.66e+06. What is the difference between the Aid flow from UN agencies (US$) of Caribbean small states in 1998 and the Aid flow from UN agencies (US$) of United Arab Emirates in 1999?
Your response must be concise. 4.75e+06. What is the difference between the Aid flow from UN agencies (US$) in Djibouti in 1998 and the Aid flow from UN agencies (US$) in Indonesia in 1999?
Give a very brief answer. -5.98e+06. What is the difference between the Aid flow from UN agencies (US$) of Indonesia in 1998 and the Aid flow from UN agencies (US$) of United Arab Emirates in 1999?
Ensure brevity in your answer.  3.72e+06. What is the average Aid flow from UN agencies (US$) in Caribbean small states per year?
Offer a terse response. 5.61e+06. What is the average Aid flow from UN agencies (US$) in Djibouti per year?
Offer a very short reply. 1.11e+06. What is the average Aid flow from UN agencies (US$) of Indonesia per year?
Provide a succinct answer. 6.78e+06. What is the average Aid flow from UN agencies (US$) in United Arab Emirates per year?
Your response must be concise. 2.41e+05. In the year 1992, what is the difference between the Aid flow from UN agencies (US$) of Caribbean small states and Aid flow from UN agencies (US$) of Djibouti?
Your answer should be compact. 3.70e+06. In the year 1992, what is the difference between the Aid flow from UN agencies (US$) in Caribbean small states and Aid flow from UN agencies (US$) in Indonesia?
Ensure brevity in your answer.  -1.48e+06. In the year 1992, what is the difference between the Aid flow from UN agencies (US$) of Caribbean small states and Aid flow from UN agencies (US$) of United Arab Emirates?
Provide a succinct answer. 4.22e+06. In the year 1992, what is the difference between the Aid flow from UN agencies (US$) in Djibouti and Aid flow from UN agencies (US$) in Indonesia?
Provide a short and direct response. -5.18e+06. In the year 1992, what is the difference between the Aid flow from UN agencies (US$) in Djibouti and Aid flow from UN agencies (US$) in United Arab Emirates?
Keep it short and to the point. 5.20e+05. In the year 1992, what is the difference between the Aid flow from UN agencies (US$) in Indonesia and Aid flow from UN agencies (US$) in United Arab Emirates?
Keep it short and to the point. 5.70e+06. In the year 1993, what is the difference between the Aid flow from UN agencies (US$) of Caribbean small states and Aid flow from UN agencies (US$) of Djibouti?
Give a very brief answer. 4.14e+06. In the year 1993, what is the difference between the Aid flow from UN agencies (US$) of Caribbean small states and Aid flow from UN agencies (US$) of Indonesia?
Offer a very short reply. -3.38e+06. In the year 1993, what is the difference between the Aid flow from UN agencies (US$) of Caribbean small states and Aid flow from UN agencies (US$) of United Arab Emirates?
Make the answer very short. 4.97e+06. In the year 1993, what is the difference between the Aid flow from UN agencies (US$) in Djibouti and Aid flow from UN agencies (US$) in Indonesia?
Keep it short and to the point. -7.52e+06. In the year 1993, what is the difference between the Aid flow from UN agencies (US$) in Djibouti and Aid flow from UN agencies (US$) in United Arab Emirates?
Your answer should be very brief. 8.30e+05. In the year 1993, what is the difference between the Aid flow from UN agencies (US$) in Indonesia and Aid flow from UN agencies (US$) in United Arab Emirates?
Provide a short and direct response. 8.35e+06. In the year 1994, what is the difference between the Aid flow from UN agencies (US$) in Caribbean small states and Aid flow from UN agencies (US$) in Djibouti?
Make the answer very short. 3.65e+06. In the year 1994, what is the difference between the Aid flow from UN agencies (US$) of Caribbean small states and Aid flow from UN agencies (US$) of Indonesia?
Offer a terse response. -1.45e+06. In the year 1994, what is the difference between the Aid flow from UN agencies (US$) in Caribbean small states and Aid flow from UN agencies (US$) in United Arab Emirates?
Provide a short and direct response. 4.28e+06. In the year 1994, what is the difference between the Aid flow from UN agencies (US$) in Djibouti and Aid flow from UN agencies (US$) in Indonesia?
Keep it short and to the point. -5.10e+06. In the year 1994, what is the difference between the Aid flow from UN agencies (US$) of Djibouti and Aid flow from UN agencies (US$) of United Arab Emirates?
Offer a very short reply. 6.30e+05. In the year 1994, what is the difference between the Aid flow from UN agencies (US$) in Indonesia and Aid flow from UN agencies (US$) in United Arab Emirates?
Offer a very short reply. 5.73e+06. In the year 1995, what is the difference between the Aid flow from UN agencies (US$) of Caribbean small states and Aid flow from UN agencies (US$) of Djibouti?
Make the answer very short. 6.67e+06. In the year 1995, what is the difference between the Aid flow from UN agencies (US$) of Caribbean small states and Aid flow from UN agencies (US$) of Indonesia?
Provide a short and direct response. -4.38e+06. In the year 1995, what is the difference between the Aid flow from UN agencies (US$) in Caribbean small states and Aid flow from UN agencies (US$) in United Arab Emirates?
Provide a short and direct response. 8.08e+06. In the year 1995, what is the difference between the Aid flow from UN agencies (US$) of Djibouti and Aid flow from UN agencies (US$) of Indonesia?
Give a very brief answer. -1.10e+07. In the year 1995, what is the difference between the Aid flow from UN agencies (US$) in Djibouti and Aid flow from UN agencies (US$) in United Arab Emirates?
Your response must be concise. 1.41e+06. In the year 1995, what is the difference between the Aid flow from UN agencies (US$) in Indonesia and Aid flow from UN agencies (US$) in United Arab Emirates?
Give a very brief answer. 1.25e+07. In the year 1996, what is the difference between the Aid flow from UN agencies (US$) of Caribbean small states and Aid flow from UN agencies (US$) of Djibouti?
Keep it short and to the point. 3.97e+06. In the year 1996, what is the difference between the Aid flow from UN agencies (US$) in Caribbean small states and Aid flow from UN agencies (US$) in Indonesia?
Offer a terse response. 1.34e+06. In the year 1996, what is the difference between the Aid flow from UN agencies (US$) in Caribbean small states and Aid flow from UN agencies (US$) in United Arab Emirates?
Your answer should be compact. 4.90e+06. In the year 1996, what is the difference between the Aid flow from UN agencies (US$) in Djibouti and Aid flow from UN agencies (US$) in Indonesia?
Offer a very short reply. -2.63e+06. In the year 1996, what is the difference between the Aid flow from UN agencies (US$) in Djibouti and Aid flow from UN agencies (US$) in United Arab Emirates?
Offer a very short reply. 9.30e+05. In the year 1996, what is the difference between the Aid flow from UN agencies (US$) of Indonesia and Aid flow from UN agencies (US$) of United Arab Emirates?
Your answer should be compact. 3.56e+06. In the year 1997, what is the difference between the Aid flow from UN agencies (US$) in Caribbean small states and Aid flow from UN agencies (US$) in Djibouti?
Your answer should be very brief. 4.08e+06. In the year 1997, what is the difference between the Aid flow from UN agencies (US$) in Caribbean small states and Aid flow from UN agencies (US$) in Indonesia?
Offer a very short reply. -1.26e+06. In the year 1997, what is the difference between the Aid flow from UN agencies (US$) in Caribbean small states and Aid flow from UN agencies (US$) in United Arab Emirates?
Keep it short and to the point. 5.03e+06. In the year 1997, what is the difference between the Aid flow from UN agencies (US$) in Djibouti and Aid flow from UN agencies (US$) in Indonesia?
Offer a very short reply. -5.34e+06. In the year 1997, what is the difference between the Aid flow from UN agencies (US$) of Djibouti and Aid flow from UN agencies (US$) of United Arab Emirates?
Keep it short and to the point. 9.50e+05. In the year 1997, what is the difference between the Aid flow from UN agencies (US$) in Indonesia and Aid flow from UN agencies (US$) in United Arab Emirates?
Ensure brevity in your answer.  6.29e+06. In the year 1998, what is the difference between the Aid flow from UN agencies (US$) in Caribbean small states and Aid flow from UN agencies (US$) in Djibouti?
Provide a succinct answer. 4.32e+06. In the year 1998, what is the difference between the Aid flow from UN agencies (US$) in Caribbean small states and Aid flow from UN agencies (US$) in Indonesia?
Your answer should be compact. 1.03e+06. In the year 1998, what is the difference between the Aid flow from UN agencies (US$) in Caribbean small states and Aid flow from UN agencies (US$) in United Arab Emirates?
Keep it short and to the point. 4.87e+06. In the year 1998, what is the difference between the Aid flow from UN agencies (US$) in Djibouti and Aid flow from UN agencies (US$) in Indonesia?
Provide a short and direct response. -3.29e+06. In the year 1998, what is the difference between the Aid flow from UN agencies (US$) in Indonesia and Aid flow from UN agencies (US$) in United Arab Emirates?
Keep it short and to the point. 3.84e+06. In the year 1999, what is the difference between the Aid flow from UN agencies (US$) of Caribbean small states and Aid flow from UN agencies (US$) of Djibouti?
Ensure brevity in your answer.  5.46e+06. In the year 1999, what is the difference between the Aid flow from UN agencies (US$) of Caribbean small states and Aid flow from UN agencies (US$) of Indonesia?
Your answer should be compact. 1.80e+05. In the year 1999, what is the difference between the Aid flow from UN agencies (US$) in Caribbean small states and Aid flow from UN agencies (US$) in United Arab Emirates?
Your response must be concise. 6.59e+06. In the year 1999, what is the difference between the Aid flow from UN agencies (US$) in Djibouti and Aid flow from UN agencies (US$) in Indonesia?
Offer a very short reply. -5.28e+06. In the year 1999, what is the difference between the Aid flow from UN agencies (US$) in Djibouti and Aid flow from UN agencies (US$) in United Arab Emirates?
Offer a terse response. 1.13e+06. In the year 1999, what is the difference between the Aid flow from UN agencies (US$) in Indonesia and Aid flow from UN agencies (US$) in United Arab Emirates?
Offer a terse response. 6.41e+06. What is the ratio of the Aid flow from UN agencies (US$) of Caribbean small states in 1992 to that in 1993?
Provide a short and direct response. 0.82. What is the ratio of the Aid flow from UN agencies (US$) of Djibouti in 1992 to that in 1993?
Your answer should be compact. 0.53. What is the ratio of the Aid flow from UN agencies (US$) in Indonesia in 1992 to that in 1993?
Your answer should be compact. 0.67. What is the ratio of the Aid flow from UN agencies (US$) in United Arab Emirates in 1992 to that in 1993?
Your response must be concise. 0.27. What is the ratio of the Aid flow from UN agencies (US$) of Caribbean small states in 1992 to that in 1994?
Give a very brief answer. 0.94. What is the ratio of the Aid flow from UN agencies (US$) in Djibouti in 1992 to that in 1994?
Give a very brief answer. 0.64. What is the ratio of the Aid flow from UN agencies (US$) of Indonesia in 1992 to that in 1994?
Offer a terse response. 0.96. What is the ratio of the Aid flow from UN agencies (US$) of United Arab Emirates in 1992 to that in 1994?
Your response must be concise. 0.26. What is the ratio of the Aid flow from UN agencies (US$) in Caribbean small states in 1992 to that in 1995?
Provide a short and direct response. 0.5. What is the ratio of the Aid flow from UN agencies (US$) of Djibouti in 1992 to that in 1995?
Provide a short and direct response. 0.32. What is the ratio of the Aid flow from UN agencies (US$) in Indonesia in 1992 to that in 1995?
Provide a succinct answer. 0.45. What is the ratio of the Aid flow from UN agencies (US$) of United Arab Emirates in 1992 to that in 1995?
Provide a short and direct response. 0.17. What is the ratio of the Aid flow from UN agencies (US$) in Caribbean small states in 1992 to that in 1996?
Your answer should be compact. 0.86. What is the ratio of the Aid flow from UN agencies (US$) of Djibouti in 1992 to that in 1996?
Your answer should be very brief. 0.58. What is the ratio of the Aid flow from UN agencies (US$) in Indonesia in 1992 to that in 1996?
Keep it short and to the point. 1.57. What is the ratio of the Aid flow from UN agencies (US$) of United Arab Emirates in 1992 to that in 1996?
Make the answer very short. 0.73. What is the ratio of the Aid flow from UN agencies (US$) of Caribbean small states in 1992 to that in 1997?
Provide a succinct answer. 0.81. What is the ratio of the Aid flow from UN agencies (US$) in Djibouti in 1992 to that in 1997?
Give a very brief answer. 0.48. What is the ratio of the Aid flow from UN agencies (US$) of Indonesia in 1992 to that in 1997?
Offer a very short reply. 0.88. What is the ratio of the Aid flow from UN agencies (US$) of United Arab Emirates in 1992 to that in 1997?
Your answer should be compact. 0.27. What is the ratio of the Aid flow from UN agencies (US$) of Caribbean small states in 1992 to that in 1998?
Give a very brief answer. 0.86. What is the ratio of the Aid flow from UN agencies (US$) of Djibouti in 1992 to that in 1998?
Your answer should be very brief. 0.9. What is the ratio of the Aid flow from UN agencies (US$) in Indonesia in 1992 to that in 1998?
Give a very brief answer. 1.46. What is the ratio of the Aid flow from UN agencies (US$) in United Arab Emirates in 1992 to that in 1998?
Offer a very short reply. 0.67. What is the ratio of the Aid flow from UN agencies (US$) of Caribbean small states in 1992 to that in 1999?
Make the answer very short. 0.63. What is the ratio of the Aid flow from UN agencies (US$) of Djibouti in 1992 to that in 1999?
Your response must be concise. 0.44. What is the ratio of the Aid flow from UN agencies (US$) of Indonesia in 1992 to that in 1999?
Provide a short and direct response. 0.87. What is the ratio of the Aid flow from UN agencies (US$) of United Arab Emirates in 1992 to that in 1999?
Keep it short and to the point. 0.33. What is the ratio of the Aid flow from UN agencies (US$) in Caribbean small states in 1993 to that in 1994?
Your answer should be very brief. 1.15. What is the ratio of the Aid flow from UN agencies (US$) in Djibouti in 1993 to that in 1994?
Provide a succinct answer. 1.2. What is the ratio of the Aid flow from UN agencies (US$) in Indonesia in 1993 to that in 1994?
Offer a terse response. 1.43. What is the ratio of the Aid flow from UN agencies (US$) in United Arab Emirates in 1993 to that in 1994?
Provide a short and direct response. 0.97. What is the ratio of the Aid flow from UN agencies (US$) in Caribbean small states in 1993 to that in 1995?
Your answer should be compact. 0.62. What is the ratio of the Aid flow from UN agencies (US$) of Djibouti in 1993 to that in 1995?
Your answer should be compact. 0.6. What is the ratio of the Aid flow from UN agencies (US$) of Indonesia in 1993 to that in 1995?
Your response must be concise. 0.67. What is the ratio of the Aid flow from UN agencies (US$) in United Arab Emirates in 1993 to that in 1995?
Provide a succinct answer. 0.64. What is the ratio of the Aid flow from UN agencies (US$) in Caribbean small states in 1993 to that in 1996?
Your answer should be compact. 1.05. What is the ratio of the Aid flow from UN agencies (US$) in Djibouti in 1993 to that in 1996?
Your answer should be compact. 1.09. What is the ratio of the Aid flow from UN agencies (US$) of Indonesia in 1993 to that in 1996?
Offer a terse response. 2.36. What is the ratio of the Aid flow from UN agencies (US$) in United Arab Emirates in 1993 to that in 1996?
Offer a terse response. 2.73. What is the ratio of the Aid flow from UN agencies (US$) of Caribbean small states in 1993 to that in 1997?
Provide a succinct answer. 0.99. What is the ratio of the Aid flow from UN agencies (US$) in Djibouti in 1993 to that in 1997?
Ensure brevity in your answer.  0.9. What is the ratio of the Aid flow from UN agencies (US$) in Indonesia in 1993 to that in 1997?
Ensure brevity in your answer.  1.31. What is the ratio of the Aid flow from UN agencies (US$) in Caribbean small states in 1993 to that in 1998?
Make the answer very short. 1.06. What is the ratio of the Aid flow from UN agencies (US$) of Djibouti in 1993 to that in 1998?
Make the answer very short. 1.69. What is the ratio of the Aid flow from UN agencies (US$) of Indonesia in 1993 to that in 1998?
Offer a terse response. 2.18. What is the ratio of the Aid flow from UN agencies (US$) in United Arab Emirates in 1993 to that in 1998?
Make the answer very short. 2.5. What is the ratio of the Aid flow from UN agencies (US$) in Caribbean small states in 1993 to that in 1999?
Provide a succinct answer. 0.77. What is the ratio of the Aid flow from UN agencies (US$) in Djibouti in 1993 to that in 1999?
Offer a terse response. 0.82. What is the ratio of the Aid flow from UN agencies (US$) in Indonesia in 1993 to that in 1999?
Your answer should be very brief. 1.3. What is the ratio of the Aid flow from UN agencies (US$) in Caribbean small states in 1994 to that in 1995?
Your answer should be compact. 0.54. What is the ratio of the Aid flow from UN agencies (US$) in Indonesia in 1994 to that in 1995?
Provide a short and direct response. 0.47. What is the ratio of the Aid flow from UN agencies (US$) of United Arab Emirates in 1994 to that in 1995?
Ensure brevity in your answer.  0.66. What is the ratio of the Aid flow from UN agencies (US$) of Caribbean small states in 1994 to that in 1996?
Offer a very short reply. 0.92. What is the ratio of the Aid flow from UN agencies (US$) in Djibouti in 1994 to that in 1996?
Offer a terse response. 0.9. What is the ratio of the Aid flow from UN agencies (US$) in Indonesia in 1994 to that in 1996?
Your answer should be very brief. 1.65. What is the ratio of the Aid flow from UN agencies (US$) in United Arab Emirates in 1994 to that in 1996?
Give a very brief answer. 2.82. What is the ratio of the Aid flow from UN agencies (US$) in Caribbean small states in 1994 to that in 1997?
Your answer should be very brief. 0.86. What is the ratio of the Aid flow from UN agencies (US$) of Djibouti in 1994 to that in 1997?
Provide a succinct answer. 0.75. What is the ratio of the Aid flow from UN agencies (US$) of Indonesia in 1994 to that in 1997?
Your response must be concise. 0.92. What is the ratio of the Aid flow from UN agencies (US$) in Caribbean small states in 1994 to that in 1998?
Give a very brief answer. 0.92. What is the ratio of the Aid flow from UN agencies (US$) in Djibouti in 1994 to that in 1998?
Your answer should be compact. 1.4. What is the ratio of the Aid flow from UN agencies (US$) in Indonesia in 1994 to that in 1998?
Keep it short and to the point. 1.53. What is the ratio of the Aid flow from UN agencies (US$) in United Arab Emirates in 1994 to that in 1998?
Ensure brevity in your answer.  2.58. What is the ratio of the Aid flow from UN agencies (US$) of Caribbean small states in 1994 to that in 1999?
Your response must be concise. 0.67. What is the ratio of the Aid flow from UN agencies (US$) in Djibouti in 1994 to that in 1999?
Give a very brief answer. 0.69. What is the ratio of the Aid flow from UN agencies (US$) in Indonesia in 1994 to that in 1999?
Give a very brief answer. 0.91. What is the ratio of the Aid flow from UN agencies (US$) in United Arab Emirates in 1994 to that in 1999?
Your answer should be compact. 1.29. What is the ratio of the Aid flow from UN agencies (US$) in Caribbean small states in 1995 to that in 1996?
Offer a terse response. 1.71. What is the ratio of the Aid flow from UN agencies (US$) in Djibouti in 1995 to that in 1996?
Provide a short and direct response. 1.81. What is the ratio of the Aid flow from UN agencies (US$) in Indonesia in 1995 to that in 1996?
Give a very brief answer. 3.52. What is the ratio of the Aid flow from UN agencies (US$) of United Arab Emirates in 1995 to that in 1996?
Provide a short and direct response. 4.27. What is the ratio of the Aid flow from UN agencies (US$) in Caribbean small states in 1995 to that in 1997?
Offer a terse response. 1.6. What is the ratio of the Aid flow from UN agencies (US$) in Djibouti in 1995 to that in 1997?
Your answer should be compact. 1.5. What is the ratio of the Aid flow from UN agencies (US$) in Indonesia in 1995 to that in 1997?
Give a very brief answer. 1.96. What is the ratio of the Aid flow from UN agencies (US$) of United Arab Emirates in 1995 to that in 1997?
Make the answer very short. 1.57. What is the ratio of the Aid flow from UN agencies (US$) of Caribbean small states in 1995 to that in 1998?
Your answer should be very brief. 1.71. What is the ratio of the Aid flow from UN agencies (US$) of Djibouti in 1995 to that in 1998?
Offer a terse response. 2.81. What is the ratio of the Aid flow from UN agencies (US$) of Indonesia in 1995 to that in 1998?
Keep it short and to the point. 3.27. What is the ratio of the Aid flow from UN agencies (US$) in United Arab Emirates in 1995 to that in 1998?
Give a very brief answer. 3.92. What is the ratio of the Aid flow from UN agencies (US$) of Caribbean small states in 1995 to that in 1999?
Your answer should be compact. 1.25. What is the ratio of the Aid flow from UN agencies (US$) of Djibouti in 1995 to that in 1999?
Provide a succinct answer. 1.37. What is the ratio of the Aid flow from UN agencies (US$) in Indonesia in 1995 to that in 1999?
Offer a terse response. 1.94. What is the ratio of the Aid flow from UN agencies (US$) of United Arab Emirates in 1995 to that in 1999?
Provide a succinct answer. 1.96. What is the ratio of the Aid flow from UN agencies (US$) of Caribbean small states in 1996 to that in 1997?
Your response must be concise. 0.94. What is the ratio of the Aid flow from UN agencies (US$) of Djibouti in 1996 to that in 1997?
Provide a succinct answer. 0.83. What is the ratio of the Aid flow from UN agencies (US$) of Indonesia in 1996 to that in 1997?
Give a very brief answer. 0.56. What is the ratio of the Aid flow from UN agencies (US$) in United Arab Emirates in 1996 to that in 1997?
Make the answer very short. 0.37. What is the ratio of the Aid flow from UN agencies (US$) in Djibouti in 1996 to that in 1998?
Make the answer very short. 1.55. What is the ratio of the Aid flow from UN agencies (US$) of Indonesia in 1996 to that in 1998?
Your answer should be very brief. 0.93. What is the ratio of the Aid flow from UN agencies (US$) in United Arab Emirates in 1996 to that in 1998?
Offer a very short reply. 0.92. What is the ratio of the Aid flow from UN agencies (US$) of Caribbean small states in 1996 to that in 1999?
Provide a short and direct response. 0.73. What is the ratio of the Aid flow from UN agencies (US$) in Djibouti in 1996 to that in 1999?
Your response must be concise. 0.76. What is the ratio of the Aid flow from UN agencies (US$) in Indonesia in 1996 to that in 1999?
Give a very brief answer. 0.55. What is the ratio of the Aid flow from UN agencies (US$) in United Arab Emirates in 1996 to that in 1999?
Offer a terse response. 0.46. What is the ratio of the Aid flow from UN agencies (US$) in Caribbean small states in 1997 to that in 1998?
Offer a terse response. 1.07. What is the ratio of the Aid flow from UN agencies (US$) of Djibouti in 1997 to that in 1998?
Your answer should be very brief. 1.87. What is the ratio of the Aid flow from UN agencies (US$) of Indonesia in 1997 to that in 1998?
Provide a succinct answer. 1.66. What is the ratio of the Aid flow from UN agencies (US$) in Caribbean small states in 1997 to that in 1999?
Keep it short and to the point. 0.78. What is the ratio of the Aid flow from UN agencies (US$) of Djibouti in 1997 to that in 1999?
Provide a short and direct response. 0.91. What is the ratio of the Aid flow from UN agencies (US$) in Caribbean small states in 1998 to that in 1999?
Your answer should be very brief. 0.73. What is the ratio of the Aid flow from UN agencies (US$) in Djibouti in 1998 to that in 1999?
Make the answer very short. 0.49. What is the ratio of the Aid flow from UN agencies (US$) in Indonesia in 1998 to that in 1999?
Your answer should be very brief. 0.6. What is the ratio of the Aid flow from UN agencies (US$) in United Arab Emirates in 1998 to that in 1999?
Offer a terse response. 0.5. What is the difference between the highest and the second highest Aid flow from UN agencies (US$) of Caribbean small states?
Your response must be concise. 1.72e+06. What is the difference between the highest and the second highest Aid flow from UN agencies (US$) in Djibouti?
Provide a short and direct response. 5.10e+05. What is the difference between the highest and the second highest Aid flow from UN agencies (US$) of Indonesia?
Keep it short and to the point. 4.28e+06. What is the difference between the highest and the lowest Aid flow from UN agencies (US$) in Caribbean small states?
Your response must be concise. 4.25e+06. What is the difference between the highest and the lowest Aid flow from UN agencies (US$) of Djibouti?
Offer a terse response. 1.28e+06. What is the difference between the highest and the lowest Aid flow from UN agencies (US$) in Indonesia?
Give a very brief answer. 9.26e+06. 